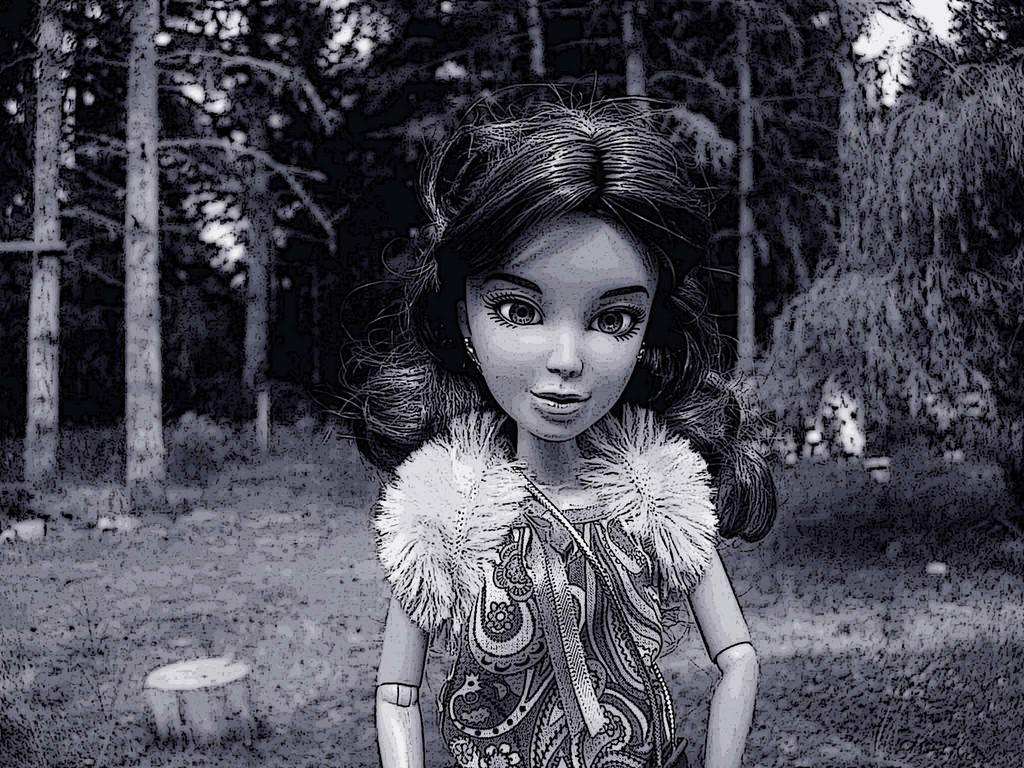Describe this image in one or two sentences. It is the black and white image in which we can see that there is a graphical image of a girl in the middle. In the background there are tall trees. On the ground there is grass. 